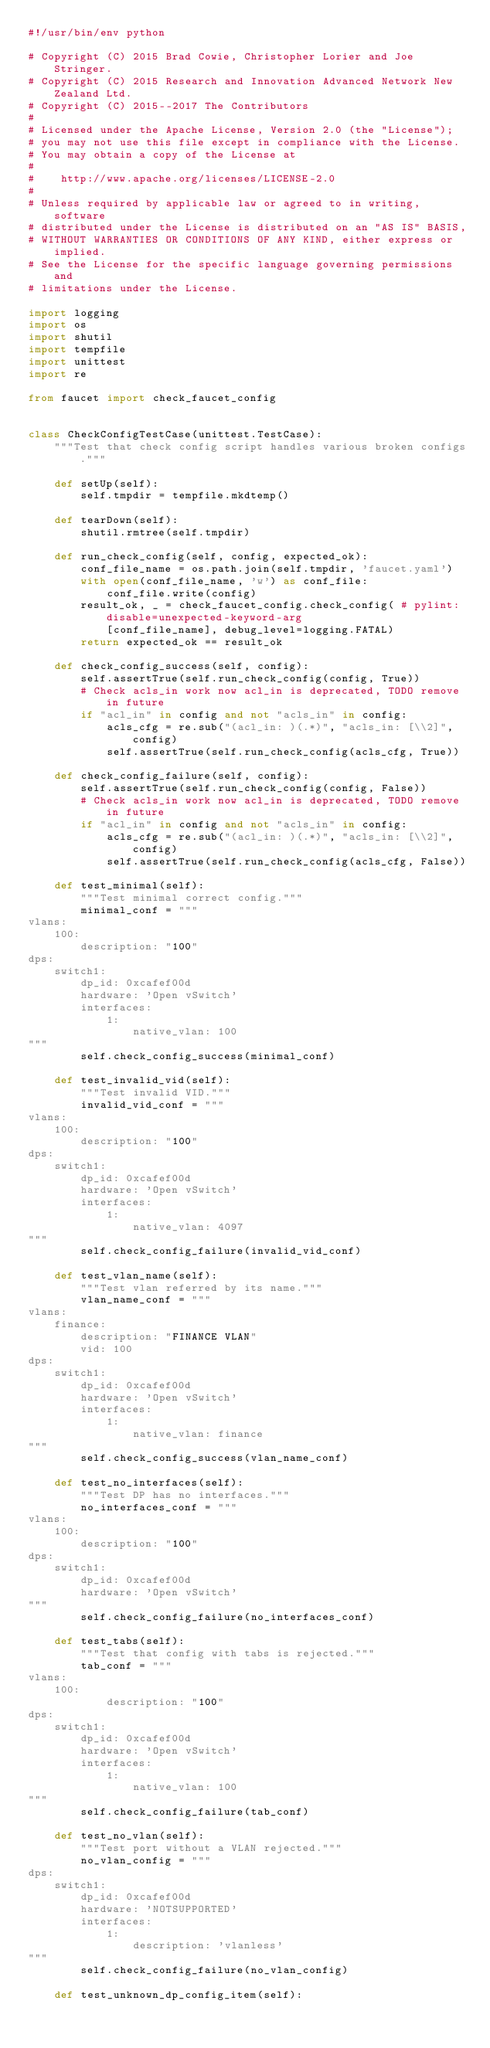<code> <loc_0><loc_0><loc_500><loc_500><_Python_>#!/usr/bin/env python

# Copyright (C) 2015 Brad Cowie, Christopher Lorier and Joe Stringer.
# Copyright (C) 2015 Research and Innovation Advanced Network New Zealand Ltd.
# Copyright (C) 2015--2017 The Contributors
#
# Licensed under the Apache License, Version 2.0 (the "License");
# you may not use this file except in compliance with the License.
# You may obtain a copy of the License at
#
#    http://www.apache.org/licenses/LICENSE-2.0
#
# Unless required by applicable law or agreed to in writing, software
# distributed under the License is distributed on an "AS IS" BASIS,
# WITHOUT WARRANTIES OR CONDITIONS OF ANY KIND, either express or implied.
# See the License for the specific language governing permissions and
# limitations under the License.

import logging
import os
import shutil
import tempfile
import unittest
import re

from faucet import check_faucet_config


class CheckConfigTestCase(unittest.TestCase):
    """Test that check config script handles various broken configs."""

    def setUp(self):
        self.tmpdir = tempfile.mkdtemp()

    def tearDown(self):
        shutil.rmtree(self.tmpdir)

    def run_check_config(self, config, expected_ok):
        conf_file_name = os.path.join(self.tmpdir, 'faucet.yaml')
        with open(conf_file_name, 'w') as conf_file:
            conf_file.write(config)
        result_ok, _ = check_faucet_config.check_config( # pylint: disable=unexpected-keyword-arg
            [conf_file_name], debug_level=logging.FATAL)
        return expected_ok == result_ok

    def check_config_success(self, config):
        self.assertTrue(self.run_check_config(config, True))
        # Check acls_in work now acl_in is deprecated, TODO remove in future
        if "acl_in" in config and not "acls_in" in config:
            acls_cfg = re.sub("(acl_in: )(.*)", "acls_in: [\\2]", config)
            self.assertTrue(self.run_check_config(acls_cfg, True))

    def check_config_failure(self, config):
        self.assertTrue(self.run_check_config(config, False))
        # Check acls_in work now acl_in is deprecated, TODO remove in future
        if "acl_in" in config and not "acls_in" in config:
            acls_cfg = re.sub("(acl_in: )(.*)", "acls_in: [\\2]", config)
            self.assertTrue(self.run_check_config(acls_cfg, False))

    def test_minimal(self):
        """Test minimal correct config."""
        minimal_conf = """
vlans:
    100:
        description: "100"
dps:
    switch1:
        dp_id: 0xcafef00d
        hardware: 'Open vSwitch'
        interfaces:
            1:
                native_vlan: 100
"""
        self.check_config_success(minimal_conf)

    def test_invalid_vid(self):
        """Test invalid VID."""
        invalid_vid_conf = """
vlans:
    100:
        description: "100"
dps:
    switch1:
        dp_id: 0xcafef00d
        hardware: 'Open vSwitch'
        interfaces:
            1:
                native_vlan: 4097
"""
        self.check_config_failure(invalid_vid_conf)

    def test_vlan_name(self):
        """Test vlan referred by its name."""
        vlan_name_conf = """
vlans:
    finance:
        description: "FINANCE VLAN"
        vid: 100
dps:
    switch1:
        dp_id: 0xcafef00d
        hardware: 'Open vSwitch'
        interfaces:
            1:
                native_vlan: finance
"""
        self.check_config_success(vlan_name_conf)

    def test_no_interfaces(self):
        """Test DP has no interfaces."""
        no_interfaces_conf = """
vlans:
    100:
        description: "100"
dps:
    switch1:
        dp_id: 0xcafef00d
        hardware: 'Open vSwitch'
"""
        self.check_config_failure(no_interfaces_conf)

    def test_tabs(self):
        """Test that config with tabs is rejected."""
        tab_conf = """
vlans:
    100:
        	description: "100"
dps:
    switch1:
        dp_id: 0xcafef00d
        hardware: 'Open vSwitch'
        interfaces:
            1:
                native_vlan: 100
"""
        self.check_config_failure(tab_conf)

    def test_no_vlan(self):
        """Test port without a VLAN rejected."""
        no_vlan_config = """
dps:
    switch1:
        dp_id: 0xcafef00d
        hardware: 'NOTSUPPORTED'
        interfaces:
            1:
                description: 'vlanless'
"""
        self.check_config_failure(no_vlan_config)

    def test_unknown_dp_config_item(self):</code> 